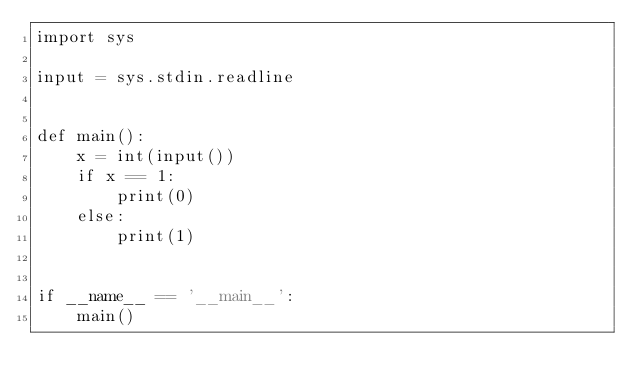<code> <loc_0><loc_0><loc_500><loc_500><_Python_>import sys

input = sys.stdin.readline


def main():
    x = int(input())
    if x == 1:
        print(0)
    else:
        print(1)


if __name__ == '__main__':
    main()
</code> 